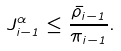<formula> <loc_0><loc_0><loc_500><loc_500>J ^ { \alpha } _ { i - 1 } \leq \frac { \bar { \rho } _ { i - 1 } } { \pi _ { i - 1 } } .</formula> 